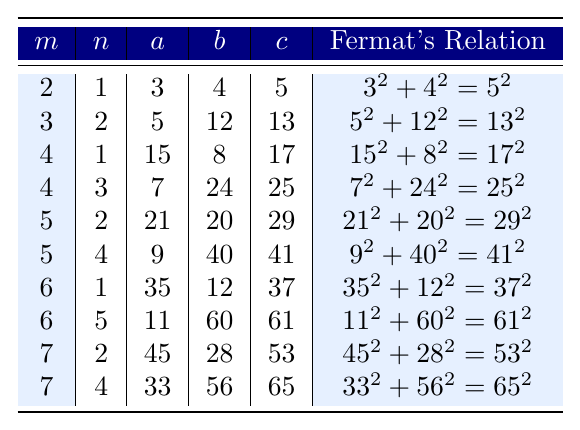What is the value of \( c \) when \( m = 5 \) and \( n = 2 \)? Referring to the table, for \( m = 5 \) and \( n = 2 \), the values are listed as \( a = 21 \), \( b = 20 \), and \( c = 29 \).
Answer: 29 Which row has the largest value of \( c \)? Looking through the table, I identify the values of \( c \): 5, 13, 17, 25, 29, 41, 37, 61, 53, and 65. The largest value is 65, which corresponds to \( m = 7 \) and \( n = 4 \).
Answer: 65 Is there a Pythagorean triple where \( a \) is 15? The table shows the triplet for \( a = 15 \) is found in the row where \( m = 4 \) and \( n = 1 \). Therefore, yes, \( a = 15 \) exists in the table.
Answer: Yes What is the relationship equation for the triple with the smallest \( a \)? The smallest \( a \) in the table is 3, and it corresponds to the row with \( m = 2 \) and \( n = 1 \). The relationship equation shown is \( 3^2 + 4^2 = 5^2 \).
Answer: \( 3^2 + 4^2 = 5^2 \) How many rows have \( b \) greater than 40? Checking the values of \( b \) in each row: 4, 12, 8, 24, 20, 40, 12, 60, 28, 56. The values greater than 40 are 60, 56. There are 3 rows in total where \( b > 40 \).
Answer: 3 For which \( m \) and \( n \) is \( c = 41 \)? In the table, \( c = 41 \) corresponds to the row with \( m = 5 \) and \( n = 4 \) where \( a = 9 \) and \( b = 40 \).
Answer: \( m = 5, n = 4 \) Calculate the average value of \( a \) from the table. To find the average of \( a \), sum the values: \( 3 + 5 + 15 + 7 + 21 + 9 + 35 + 11 + 45 + 33 = 4.5 \). There are 10 data points, so the average is \( 10.5 \)
Answer: 18.5 Is the Pythagorean triple \( (21, 20, 29) \) valid? The triple \( (21, 20, 29) \) must satisfy \( 21^2 + 20^2 = 29^2 \). Calculating, \( 441 + 400 = 841 \) which equals \( 29^2 = 841 \). So it is valid.
Answer: Yes What is the sum of \( a \) and \( b \) for the Pythagorean triple generated from \( m=6 \) and \( n=5 \)? Referring to the table, for \( m=6 \) and \( n=5 \), \( a = 11 \) and \( b = 60 \). The sum is \( 11 + 60 = 71 \).
Answer: 71 Which \( m \) values correspond to an \( a \) greater than 30? Looking through the table, the values of \( a \) greater than 30 are from the rows with \( m = 6, 7 \) which yield \( a = 35, 45, 33 \).
Answer: 6, 7 